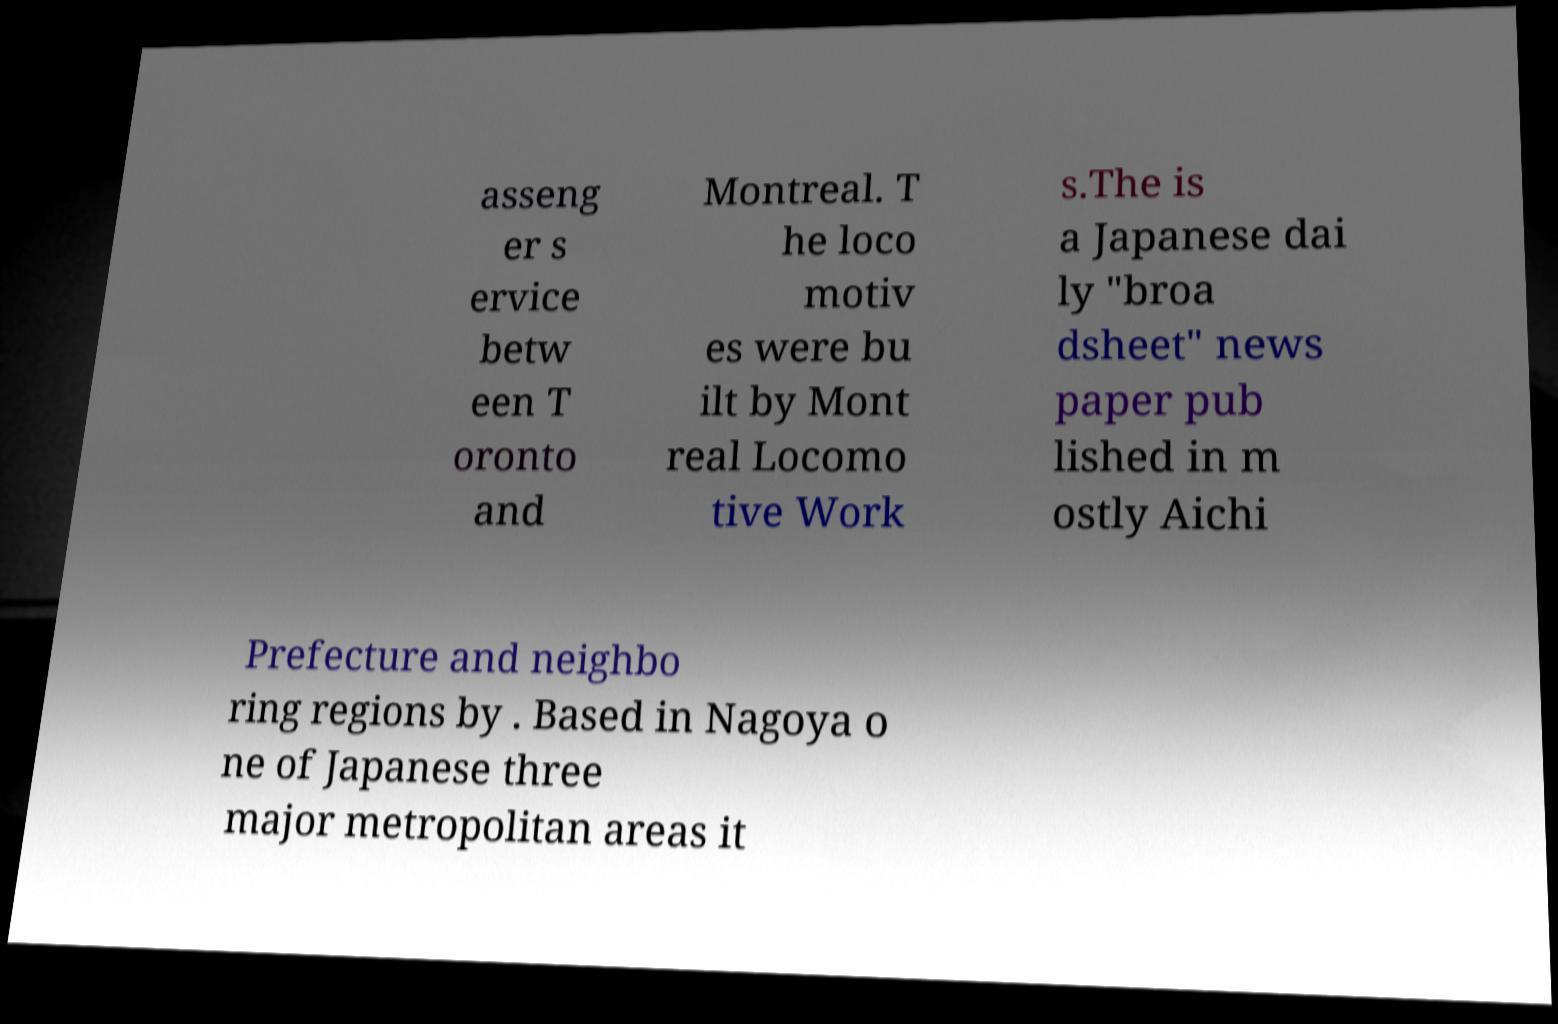Could you extract and type out the text from this image? asseng er s ervice betw een T oronto and Montreal. T he loco motiv es were bu ilt by Mont real Locomo tive Work s.The is a Japanese dai ly "broa dsheet" news paper pub lished in m ostly Aichi Prefecture and neighbo ring regions by . Based in Nagoya o ne of Japanese three major metropolitan areas it 